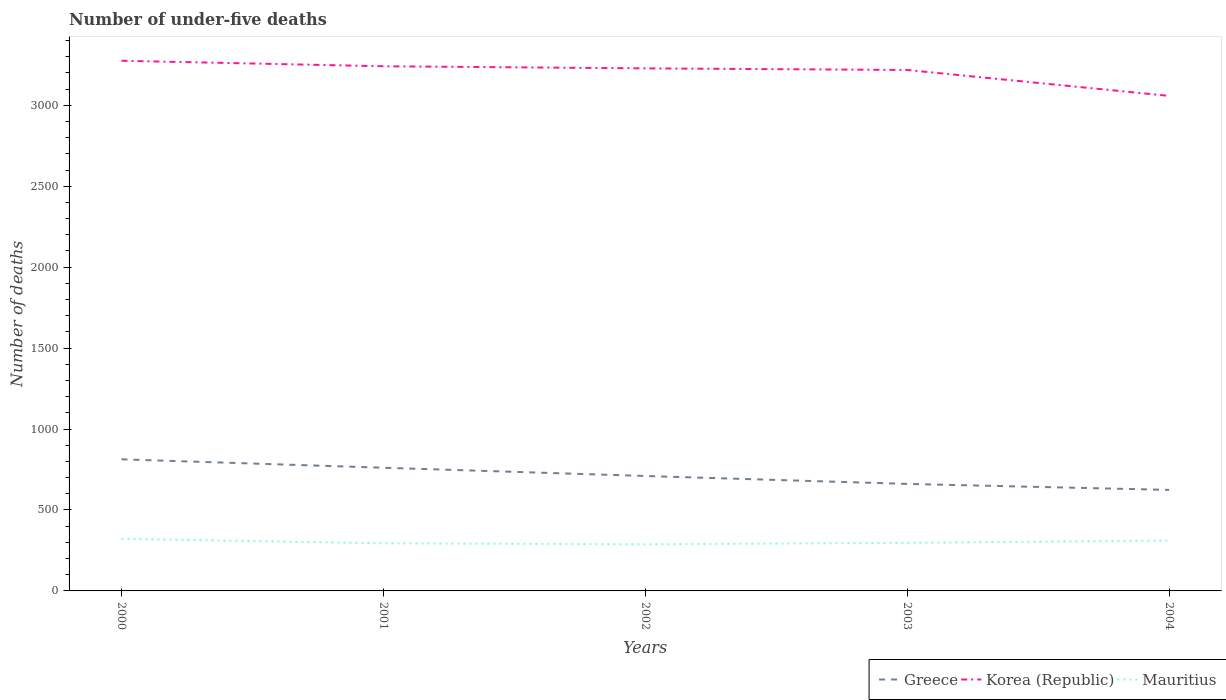Does the line corresponding to Korea (Republic) intersect with the line corresponding to Greece?
Provide a short and direct response. No. Across all years, what is the maximum number of under-five deaths in Greece?
Your answer should be very brief. 624. In which year was the number of under-five deaths in Greece maximum?
Give a very brief answer. 2004. What is the total number of under-five deaths in Mauritius in the graph?
Provide a succinct answer. -3. What is the difference between the highest and the second highest number of under-five deaths in Mauritius?
Provide a succinct answer. 34. How many lines are there?
Keep it short and to the point. 3. How many years are there in the graph?
Your answer should be very brief. 5. What is the difference between two consecutive major ticks on the Y-axis?
Provide a short and direct response. 500. Does the graph contain any zero values?
Ensure brevity in your answer.  No. Does the graph contain grids?
Your response must be concise. No. Where does the legend appear in the graph?
Your response must be concise. Bottom right. How are the legend labels stacked?
Keep it short and to the point. Horizontal. What is the title of the graph?
Your answer should be compact. Number of under-five deaths. What is the label or title of the Y-axis?
Provide a succinct answer. Number of deaths. What is the Number of deaths of Greece in 2000?
Give a very brief answer. 813. What is the Number of deaths in Korea (Republic) in 2000?
Provide a short and direct response. 3275. What is the Number of deaths of Mauritius in 2000?
Give a very brief answer. 322. What is the Number of deaths in Greece in 2001?
Your answer should be very brief. 761. What is the Number of deaths of Korea (Republic) in 2001?
Give a very brief answer. 3241. What is the Number of deaths of Mauritius in 2001?
Your response must be concise. 294. What is the Number of deaths of Greece in 2002?
Offer a terse response. 710. What is the Number of deaths of Korea (Republic) in 2002?
Your response must be concise. 3228. What is the Number of deaths of Mauritius in 2002?
Your answer should be compact. 288. What is the Number of deaths of Greece in 2003?
Your answer should be very brief. 661. What is the Number of deaths in Korea (Republic) in 2003?
Ensure brevity in your answer.  3218. What is the Number of deaths in Mauritius in 2003?
Give a very brief answer. 297. What is the Number of deaths of Greece in 2004?
Provide a short and direct response. 624. What is the Number of deaths in Korea (Republic) in 2004?
Give a very brief answer. 3058. What is the Number of deaths in Mauritius in 2004?
Ensure brevity in your answer.  311. Across all years, what is the maximum Number of deaths of Greece?
Offer a terse response. 813. Across all years, what is the maximum Number of deaths in Korea (Republic)?
Provide a succinct answer. 3275. Across all years, what is the maximum Number of deaths of Mauritius?
Your answer should be very brief. 322. Across all years, what is the minimum Number of deaths of Greece?
Your answer should be very brief. 624. Across all years, what is the minimum Number of deaths in Korea (Republic)?
Ensure brevity in your answer.  3058. Across all years, what is the minimum Number of deaths in Mauritius?
Your response must be concise. 288. What is the total Number of deaths in Greece in the graph?
Provide a short and direct response. 3569. What is the total Number of deaths in Korea (Republic) in the graph?
Give a very brief answer. 1.60e+04. What is the total Number of deaths of Mauritius in the graph?
Keep it short and to the point. 1512. What is the difference between the Number of deaths in Korea (Republic) in 2000 and that in 2001?
Ensure brevity in your answer.  34. What is the difference between the Number of deaths in Greece in 2000 and that in 2002?
Provide a short and direct response. 103. What is the difference between the Number of deaths in Korea (Republic) in 2000 and that in 2002?
Give a very brief answer. 47. What is the difference between the Number of deaths of Mauritius in 2000 and that in 2002?
Provide a short and direct response. 34. What is the difference between the Number of deaths in Greece in 2000 and that in 2003?
Give a very brief answer. 152. What is the difference between the Number of deaths in Korea (Republic) in 2000 and that in 2003?
Offer a terse response. 57. What is the difference between the Number of deaths of Mauritius in 2000 and that in 2003?
Offer a very short reply. 25. What is the difference between the Number of deaths in Greece in 2000 and that in 2004?
Your answer should be very brief. 189. What is the difference between the Number of deaths in Korea (Republic) in 2000 and that in 2004?
Ensure brevity in your answer.  217. What is the difference between the Number of deaths of Mauritius in 2000 and that in 2004?
Offer a terse response. 11. What is the difference between the Number of deaths in Korea (Republic) in 2001 and that in 2002?
Make the answer very short. 13. What is the difference between the Number of deaths in Mauritius in 2001 and that in 2002?
Offer a terse response. 6. What is the difference between the Number of deaths in Greece in 2001 and that in 2003?
Provide a succinct answer. 100. What is the difference between the Number of deaths of Greece in 2001 and that in 2004?
Ensure brevity in your answer.  137. What is the difference between the Number of deaths in Korea (Republic) in 2001 and that in 2004?
Give a very brief answer. 183. What is the difference between the Number of deaths in Greece in 2002 and that in 2003?
Keep it short and to the point. 49. What is the difference between the Number of deaths of Korea (Republic) in 2002 and that in 2003?
Your response must be concise. 10. What is the difference between the Number of deaths in Mauritius in 2002 and that in 2003?
Keep it short and to the point. -9. What is the difference between the Number of deaths in Korea (Republic) in 2002 and that in 2004?
Offer a very short reply. 170. What is the difference between the Number of deaths of Mauritius in 2002 and that in 2004?
Offer a very short reply. -23. What is the difference between the Number of deaths of Korea (Republic) in 2003 and that in 2004?
Ensure brevity in your answer.  160. What is the difference between the Number of deaths in Greece in 2000 and the Number of deaths in Korea (Republic) in 2001?
Make the answer very short. -2428. What is the difference between the Number of deaths in Greece in 2000 and the Number of deaths in Mauritius in 2001?
Your answer should be very brief. 519. What is the difference between the Number of deaths of Korea (Republic) in 2000 and the Number of deaths of Mauritius in 2001?
Ensure brevity in your answer.  2981. What is the difference between the Number of deaths in Greece in 2000 and the Number of deaths in Korea (Republic) in 2002?
Make the answer very short. -2415. What is the difference between the Number of deaths in Greece in 2000 and the Number of deaths in Mauritius in 2002?
Give a very brief answer. 525. What is the difference between the Number of deaths of Korea (Republic) in 2000 and the Number of deaths of Mauritius in 2002?
Ensure brevity in your answer.  2987. What is the difference between the Number of deaths of Greece in 2000 and the Number of deaths of Korea (Republic) in 2003?
Give a very brief answer. -2405. What is the difference between the Number of deaths in Greece in 2000 and the Number of deaths in Mauritius in 2003?
Give a very brief answer. 516. What is the difference between the Number of deaths in Korea (Republic) in 2000 and the Number of deaths in Mauritius in 2003?
Your answer should be compact. 2978. What is the difference between the Number of deaths in Greece in 2000 and the Number of deaths in Korea (Republic) in 2004?
Offer a very short reply. -2245. What is the difference between the Number of deaths in Greece in 2000 and the Number of deaths in Mauritius in 2004?
Your answer should be very brief. 502. What is the difference between the Number of deaths in Korea (Republic) in 2000 and the Number of deaths in Mauritius in 2004?
Ensure brevity in your answer.  2964. What is the difference between the Number of deaths in Greece in 2001 and the Number of deaths in Korea (Republic) in 2002?
Provide a short and direct response. -2467. What is the difference between the Number of deaths of Greece in 2001 and the Number of deaths of Mauritius in 2002?
Your response must be concise. 473. What is the difference between the Number of deaths in Korea (Republic) in 2001 and the Number of deaths in Mauritius in 2002?
Provide a short and direct response. 2953. What is the difference between the Number of deaths of Greece in 2001 and the Number of deaths of Korea (Republic) in 2003?
Ensure brevity in your answer.  -2457. What is the difference between the Number of deaths of Greece in 2001 and the Number of deaths of Mauritius in 2003?
Give a very brief answer. 464. What is the difference between the Number of deaths of Korea (Republic) in 2001 and the Number of deaths of Mauritius in 2003?
Your answer should be compact. 2944. What is the difference between the Number of deaths of Greece in 2001 and the Number of deaths of Korea (Republic) in 2004?
Your answer should be very brief. -2297. What is the difference between the Number of deaths of Greece in 2001 and the Number of deaths of Mauritius in 2004?
Give a very brief answer. 450. What is the difference between the Number of deaths in Korea (Republic) in 2001 and the Number of deaths in Mauritius in 2004?
Your answer should be compact. 2930. What is the difference between the Number of deaths in Greece in 2002 and the Number of deaths in Korea (Republic) in 2003?
Offer a very short reply. -2508. What is the difference between the Number of deaths in Greece in 2002 and the Number of deaths in Mauritius in 2003?
Your answer should be very brief. 413. What is the difference between the Number of deaths of Korea (Republic) in 2002 and the Number of deaths of Mauritius in 2003?
Make the answer very short. 2931. What is the difference between the Number of deaths of Greece in 2002 and the Number of deaths of Korea (Republic) in 2004?
Make the answer very short. -2348. What is the difference between the Number of deaths in Greece in 2002 and the Number of deaths in Mauritius in 2004?
Provide a short and direct response. 399. What is the difference between the Number of deaths in Korea (Republic) in 2002 and the Number of deaths in Mauritius in 2004?
Your response must be concise. 2917. What is the difference between the Number of deaths of Greece in 2003 and the Number of deaths of Korea (Republic) in 2004?
Ensure brevity in your answer.  -2397. What is the difference between the Number of deaths of Greece in 2003 and the Number of deaths of Mauritius in 2004?
Ensure brevity in your answer.  350. What is the difference between the Number of deaths of Korea (Republic) in 2003 and the Number of deaths of Mauritius in 2004?
Your response must be concise. 2907. What is the average Number of deaths of Greece per year?
Your response must be concise. 713.8. What is the average Number of deaths in Korea (Republic) per year?
Ensure brevity in your answer.  3204. What is the average Number of deaths in Mauritius per year?
Offer a terse response. 302.4. In the year 2000, what is the difference between the Number of deaths in Greece and Number of deaths in Korea (Republic)?
Offer a very short reply. -2462. In the year 2000, what is the difference between the Number of deaths in Greece and Number of deaths in Mauritius?
Offer a terse response. 491. In the year 2000, what is the difference between the Number of deaths of Korea (Republic) and Number of deaths of Mauritius?
Make the answer very short. 2953. In the year 2001, what is the difference between the Number of deaths in Greece and Number of deaths in Korea (Republic)?
Give a very brief answer. -2480. In the year 2001, what is the difference between the Number of deaths in Greece and Number of deaths in Mauritius?
Keep it short and to the point. 467. In the year 2001, what is the difference between the Number of deaths in Korea (Republic) and Number of deaths in Mauritius?
Provide a succinct answer. 2947. In the year 2002, what is the difference between the Number of deaths in Greece and Number of deaths in Korea (Republic)?
Provide a succinct answer. -2518. In the year 2002, what is the difference between the Number of deaths of Greece and Number of deaths of Mauritius?
Your answer should be compact. 422. In the year 2002, what is the difference between the Number of deaths in Korea (Republic) and Number of deaths in Mauritius?
Make the answer very short. 2940. In the year 2003, what is the difference between the Number of deaths in Greece and Number of deaths in Korea (Republic)?
Ensure brevity in your answer.  -2557. In the year 2003, what is the difference between the Number of deaths of Greece and Number of deaths of Mauritius?
Give a very brief answer. 364. In the year 2003, what is the difference between the Number of deaths in Korea (Republic) and Number of deaths in Mauritius?
Provide a succinct answer. 2921. In the year 2004, what is the difference between the Number of deaths of Greece and Number of deaths of Korea (Republic)?
Give a very brief answer. -2434. In the year 2004, what is the difference between the Number of deaths of Greece and Number of deaths of Mauritius?
Your answer should be compact. 313. In the year 2004, what is the difference between the Number of deaths of Korea (Republic) and Number of deaths of Mauritius?
Your answer should be very brief. 2747. What is the ratio of the Number of deaths in Greece in 2000 to that in 2001?
Give a very brief answer. 1.07. What is the ratio of the Number of deaths in Korea (Republic) in 2000 to that in 2001?
Provide a short and direct response. 1.01. What is the ratio of the Number of deaths of Mauritius in 2000 to that in 2001?
Provide a short and direct response. 1.1. What is the ratio of the Number of deaths in Greece in 2000 to that in 2002?
Provide a succinct answer. 1.15. What is the ratio of the Number of deaths of Korea (Republic) in 2000 to that in 2002?
Provide a succinct answer. 1.01. What is the ratio of the Number of deaths in Mauritius in 2000 to that in 2002?
Provide a short and direct response. 1.12. What is the ratio of the Number of deaths in Greece in 2000 to that in 2003?
Offer a very short reply. 1.23. What is the ratio of the Number of deaths in Korea (Republic) in 2000 to that in 2003?
Ensure brevity in your answer.  1.02. What is the ratio of the Number of deaths in Mauritius in 2000 to that in 2003?
Your response must be concise. 1.08. What is the ratio of the Number of deaths of Greece in 2000 to that in 2004?
Provide a succinct answer. 1.3. What is the ratio of the Number of deaths of Korea (Republic) in 2000 to that in 2004?
Provide a succinct answer. 1.07. What is the ratio of the Number of deaths of Mauritius in 2000 to that in 2004?
Offer a terse response. 1.04. What is the ratio of the Number of deaths in Greece in 2001 to that in 2002?
Ensure brevity in your answer.  1.07. What is the ratio of the Number of deaths in Mauritius in 2001 to that in 2002?
Ensure brevity in your answer.  1.02. What is the ratio of the Number of deaths in Greece in 2001 to that in 2003?
Your answer should be very brief. 1.15. What is the ratio of the Number of deaths in Korea (Republic) in 2001 to that in 2003?
Your answer should be very brief. 1.01. What is the ratio of the Number of deaths in Greece in 2001 to that in 2004?
Your answer should be compact. 1.22. What is the ratio of the Number of deaths in Korea (Republic) in 2001 to that in 2004?
Your response must be concise. 1.06. What is the ratio of the Number of deaths in Mauritius in 2001 to that in 2004?
Your answer should be very brief. 0.95. What is the ratio of the Number of deaths in Greece in 2002 to that in 2003?
Offer a very short reply. 1.07. What is the ratio of the Number of deaths in Korea (Republic) in 2002 to that in 2003?
Your answer should be compact. 1. What is the ratio of the Number of deaths in Mauritius in 2002 to that in 2003?
Ensure brevity in your answer.  0.97. What is the ratio of the Number of deaths of Greece in 2002 to that in 2004?
Your response must be concise. 1.14. What is the ratio of the Number of deaths in Korea (Republic) in 2002 to that in 2004?
Offer a very short reply. 1.06. What is the ratio of the Number of deaths in Mauritius in 2002 to that in 2004?
Your answer should be very brief. 0.93. What is the ratio of the Number of deaths in Greece in 2003 to that in 2004?
Offer a very short reply. 1.06. What is the ratio of the Number of deaths in Korea (Republic) in 2003 to that in 2004?
Your answer should be compact. 1.05. What is the ratio of the Number of deaths in Mauritius in 2003 to that in 2004?
Ensure brevity in your answer.  0.95. What is the difference between the highest and the second highest Number of deaths in Greece?
Offer a terse response. 52. What is the difference between the highest and the lowest Number of deaths of Greece?
Ensure brevity in your answer.  189. What is the difference between the highest and the lowest Number of deaths of Korea (Republic)?
Provide a succinct answer. 217. What is the difference between the highest and the lowest Number of deaths of Mauritius?
Your response must be concise. 34. 